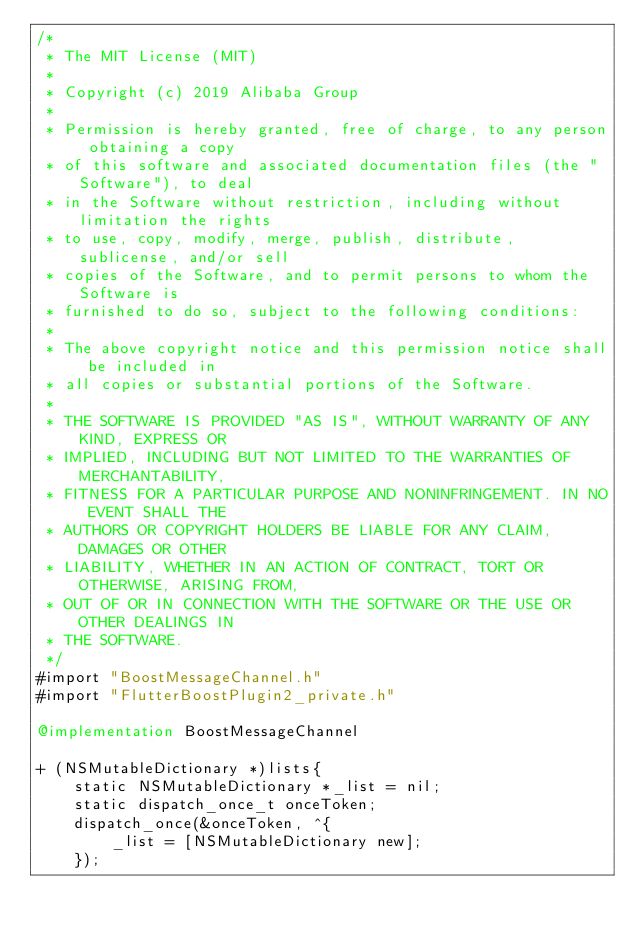<code> <loc_0><loc_0><loc_500><loc_500><_ObjectiveC_>/*
 * The MIT License (MIT)
 * 
 * Copyright (c) 2019 Alibaba Group
 * 
 * Permission is hereby granted, free of charge, to any person obtaining a copy
 * of this software and associated documentation files (the "Software"), to deal
 * in the Software without restriction, including without limitation the rights
 * to use, copy, modify, merge, publish, distribute, sublicense, and/or sell
 * copies of the Software, and to permit persons to whom the Software is
 * furnished to do so, subject to the following conditions:
 * 
 * The above copyright notice and this permission notice shall be included in
 * all copies or substantial portions of the Software.
 * 
 * THE SOFTWARE IS PROVIDED "AS IS", WITHOUT WARRANTY OF ANY KIND, EXPRESS OR
 * IMPLIED, INCLUDING BUT NOT LIMITED TO THE WARRANTIES OF MERCHANTABILITY,
 * FITNESS FOR A PARTICULAR PURPOSE AND NONINFRINGEMENT. IN NO EVENT SHALL THE
 * AUTHORS OR COPYRIGHT HOLDERS BE LIABLE FOR ANY CLAIM, DAMAGES OR OTHER
 * LIABILITY, WHETHER IN AN ACTION OF CONTRACT, TORT OR OTHERWISE, ARISING FROM,
 * OUT OF OR IN CONNECTION WITH THE SOFTWARE OR THE USE OR OTHER DEALINGS IN
 * THE SOFTWARE.
 */
#import "BoostMessageChannel.h"
#import "FlutterBoostPlugin2_private.h"

@implementation BoostMessageChannel

+ (NSMutableDictionary *)lists{
    static NSMutableDictionary *_list = nil;
    static dispatch_once_t onceToken;
    dispatch_once(&onceToken, ^{
        _list = [NSMutableDictionary new];
    });</code> 